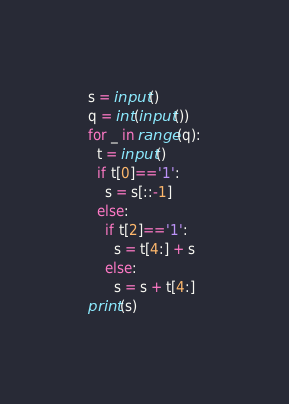<code> <loc_0><loc_0><loc_500><loc_500><_Python_>s = input()
q = int(input())
for _ in range(q):
  t = input()
  if t[0]=='1':
    s = s[::-1]
  else:
    if t[2]=='1':
      s = t[4:] + s
    else:
      s = s + t[4:]
print(s)</code> 